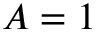<formula> <loc_0><loc_0><loc_500><loc_500>A = 1</formula> 